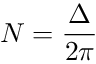Convert formula to latex. <formula><loc_0><loc_0><loc_500><loc_500>N = { \frac { \Delta } { 2 \pi } }</formula> 